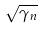Convert formula to latex. <formula><loc_0><loc_0><loc_500><loc_500>\sqrt { \gamma _ { n } }</formula> 